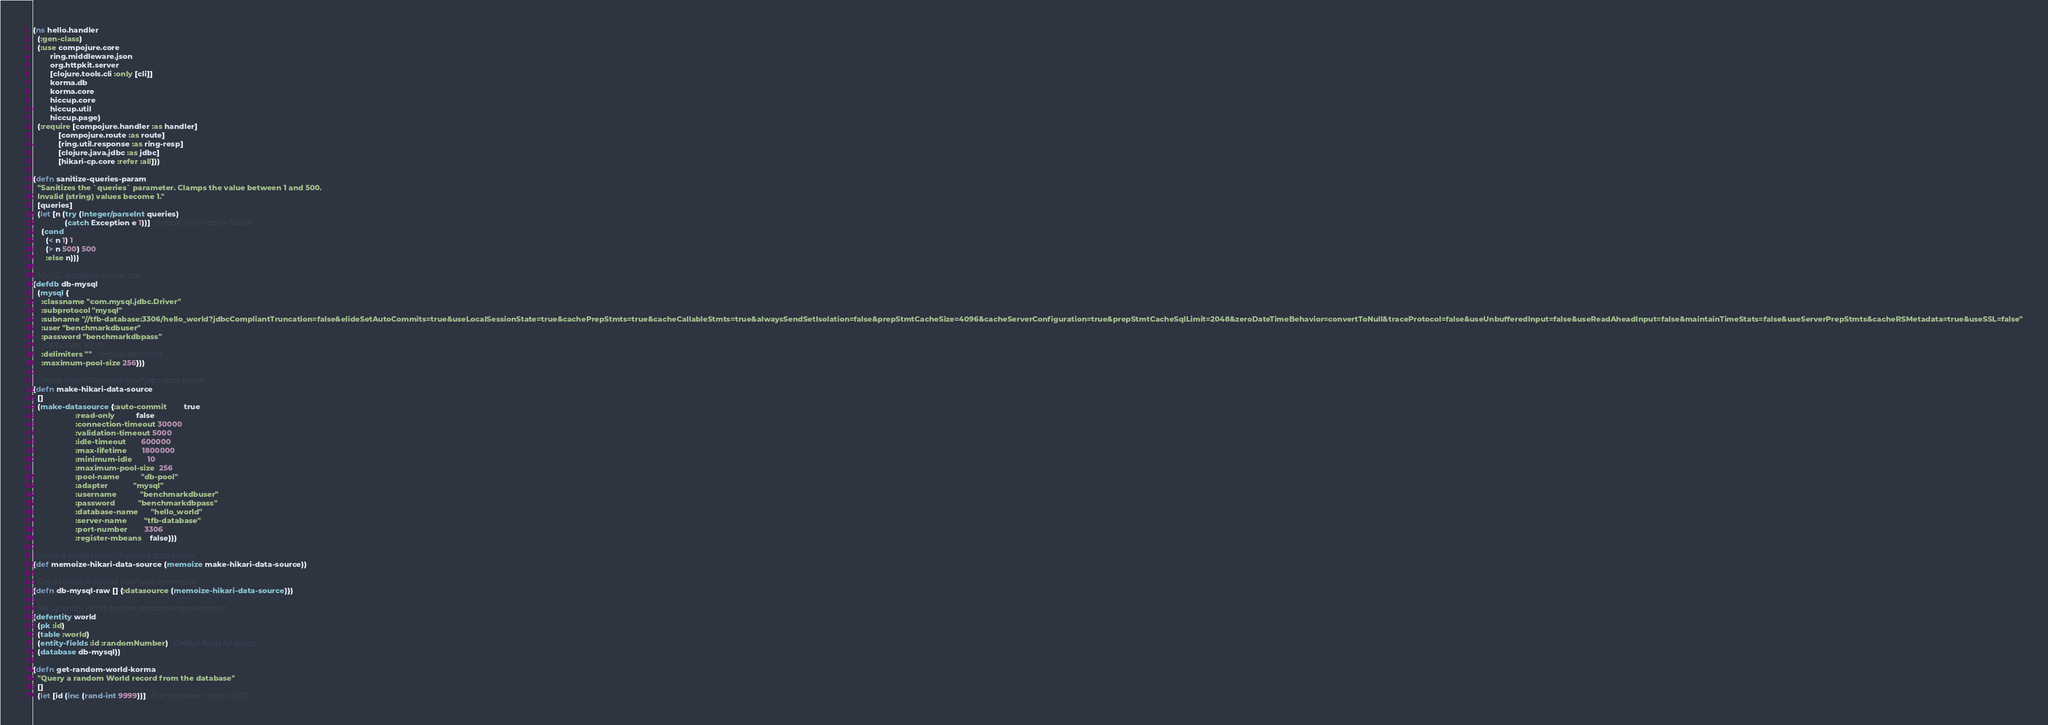<code> <loc_0><loc_0><loc_500><loc_500><_Clojure_>(ns hello.handler
  (:gen-class)
  (:use compojure.core
        ring.middleware.json
        org.httpkit.server
        [clojure.tools.cli :only [cli]]
        korma.db
        korma.core
        hiccup.core
        hiccup.util
        hiccup.page)
  (:require [compojure.handler :as handler]
            [compojure.route :as route]
            [ring.util.response :as ring-resp]
            [clojure.java.jdbc :as jdbc]
            [hikari-cp.core :refer :all]))

(defn sanitize-queries-param
  "Sanitizes the `queries` parameter. Clamps the value between 1 and 500.
  Invalid (string) values become 1."
  [queries]
  (let [n (try (Integer/parseInt queries)
               (catch Exception e 1))] ; default to 1 on parse failure
    (cond
      (< n 1) 1
      (> n 500) 500
      :else n)))

;; MySQL database connection
(defdb db-mysql
  (mysql {
    :classname "com.mysql.jdbc.Driver"
    :subprotocol "mysql"
    :subname "//tfb-database:3306/hello_world?jdbcCompliantTruncation=false&elideSetAutoCommits=true&useLocalSessionState=true&cachePrepStmts=true&cacheCallableStmts=true&alwaysSendSetIsolation=false&prepStmtCacheSize=4096&cacheServerConfiguration=true&prepStmtCacheSqlLimit=2048&zeroDateTimeBehavior=convertToNull&traceProtocol=false&useUnbufferedInput=false&useReadAheadInput=false&maintainTimeStats=false&useServerPrepStmts&cacheRSMetadata=true&useSSL=false"
    :user "benchmarkdbuser"
    :password "benchmarkdbpass"
    ;;OPTIONAL KEYS
    :delimiters "" ;; remove delimiters
    :maximum-pool-size 256}))

;; Create HikariCP-pooled "raw" jdbc data source
(defn make-hikari-data-source
  []
  (make-datasource {:auto-commit        true
                    :read-only          false
                    :connection-timeout 30000
                    :validation-timeout 5000
                    :idle-timeout       600000
                    :max-lifetime       1800000
                    :minimum-idle       10
                    :maximum-pool-size  256
                    :pool-name          "db-pool"
                    :adapter            "mysql"
                    :username           "benchmarkdbuser"
                    :password           "benchmarkdbpass"
                    :database-name      "hello_world"
                    :server-name        "tfb-database"
                    :port-number        3306
                    :register-mbeans    false}))

;; Reuse a single HikariCP-pooled data source
(def memoize-hikari-data-source (memoize make-hikari-data-source))

;; Get a HikariCP-pooled "raw" jdbc connection
(defn db-mysql-raw [] {:datasource (memoize-hikari-data-source)})

;; Set up entity World and the database representation
(defentity world
  (pk :id)
  (table :world)
  (entity-fields :id :randomNumber) ; Default fields for select
  (database db-mysql))

(defn get-random-world-korma
  "Query a random World record from the database"
  []
  (let [id (inc (rand-int 9999))] ; Num between 1 and 10,000</code> 